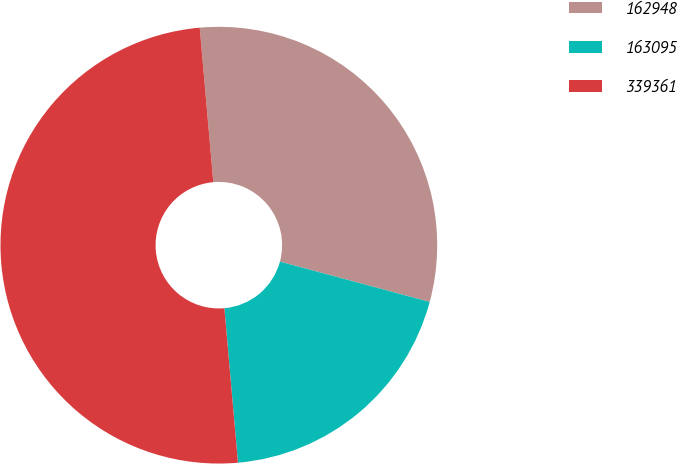Convert chart to OTSL. <chart><loc_0><loc_0><loc_500><loc_500><pie_chart><fcel>162948<fcel>163095<fcel>339361<nl><fcel>30.58%<fcel>19.42%<fcel>50.0%<nl></chart> 